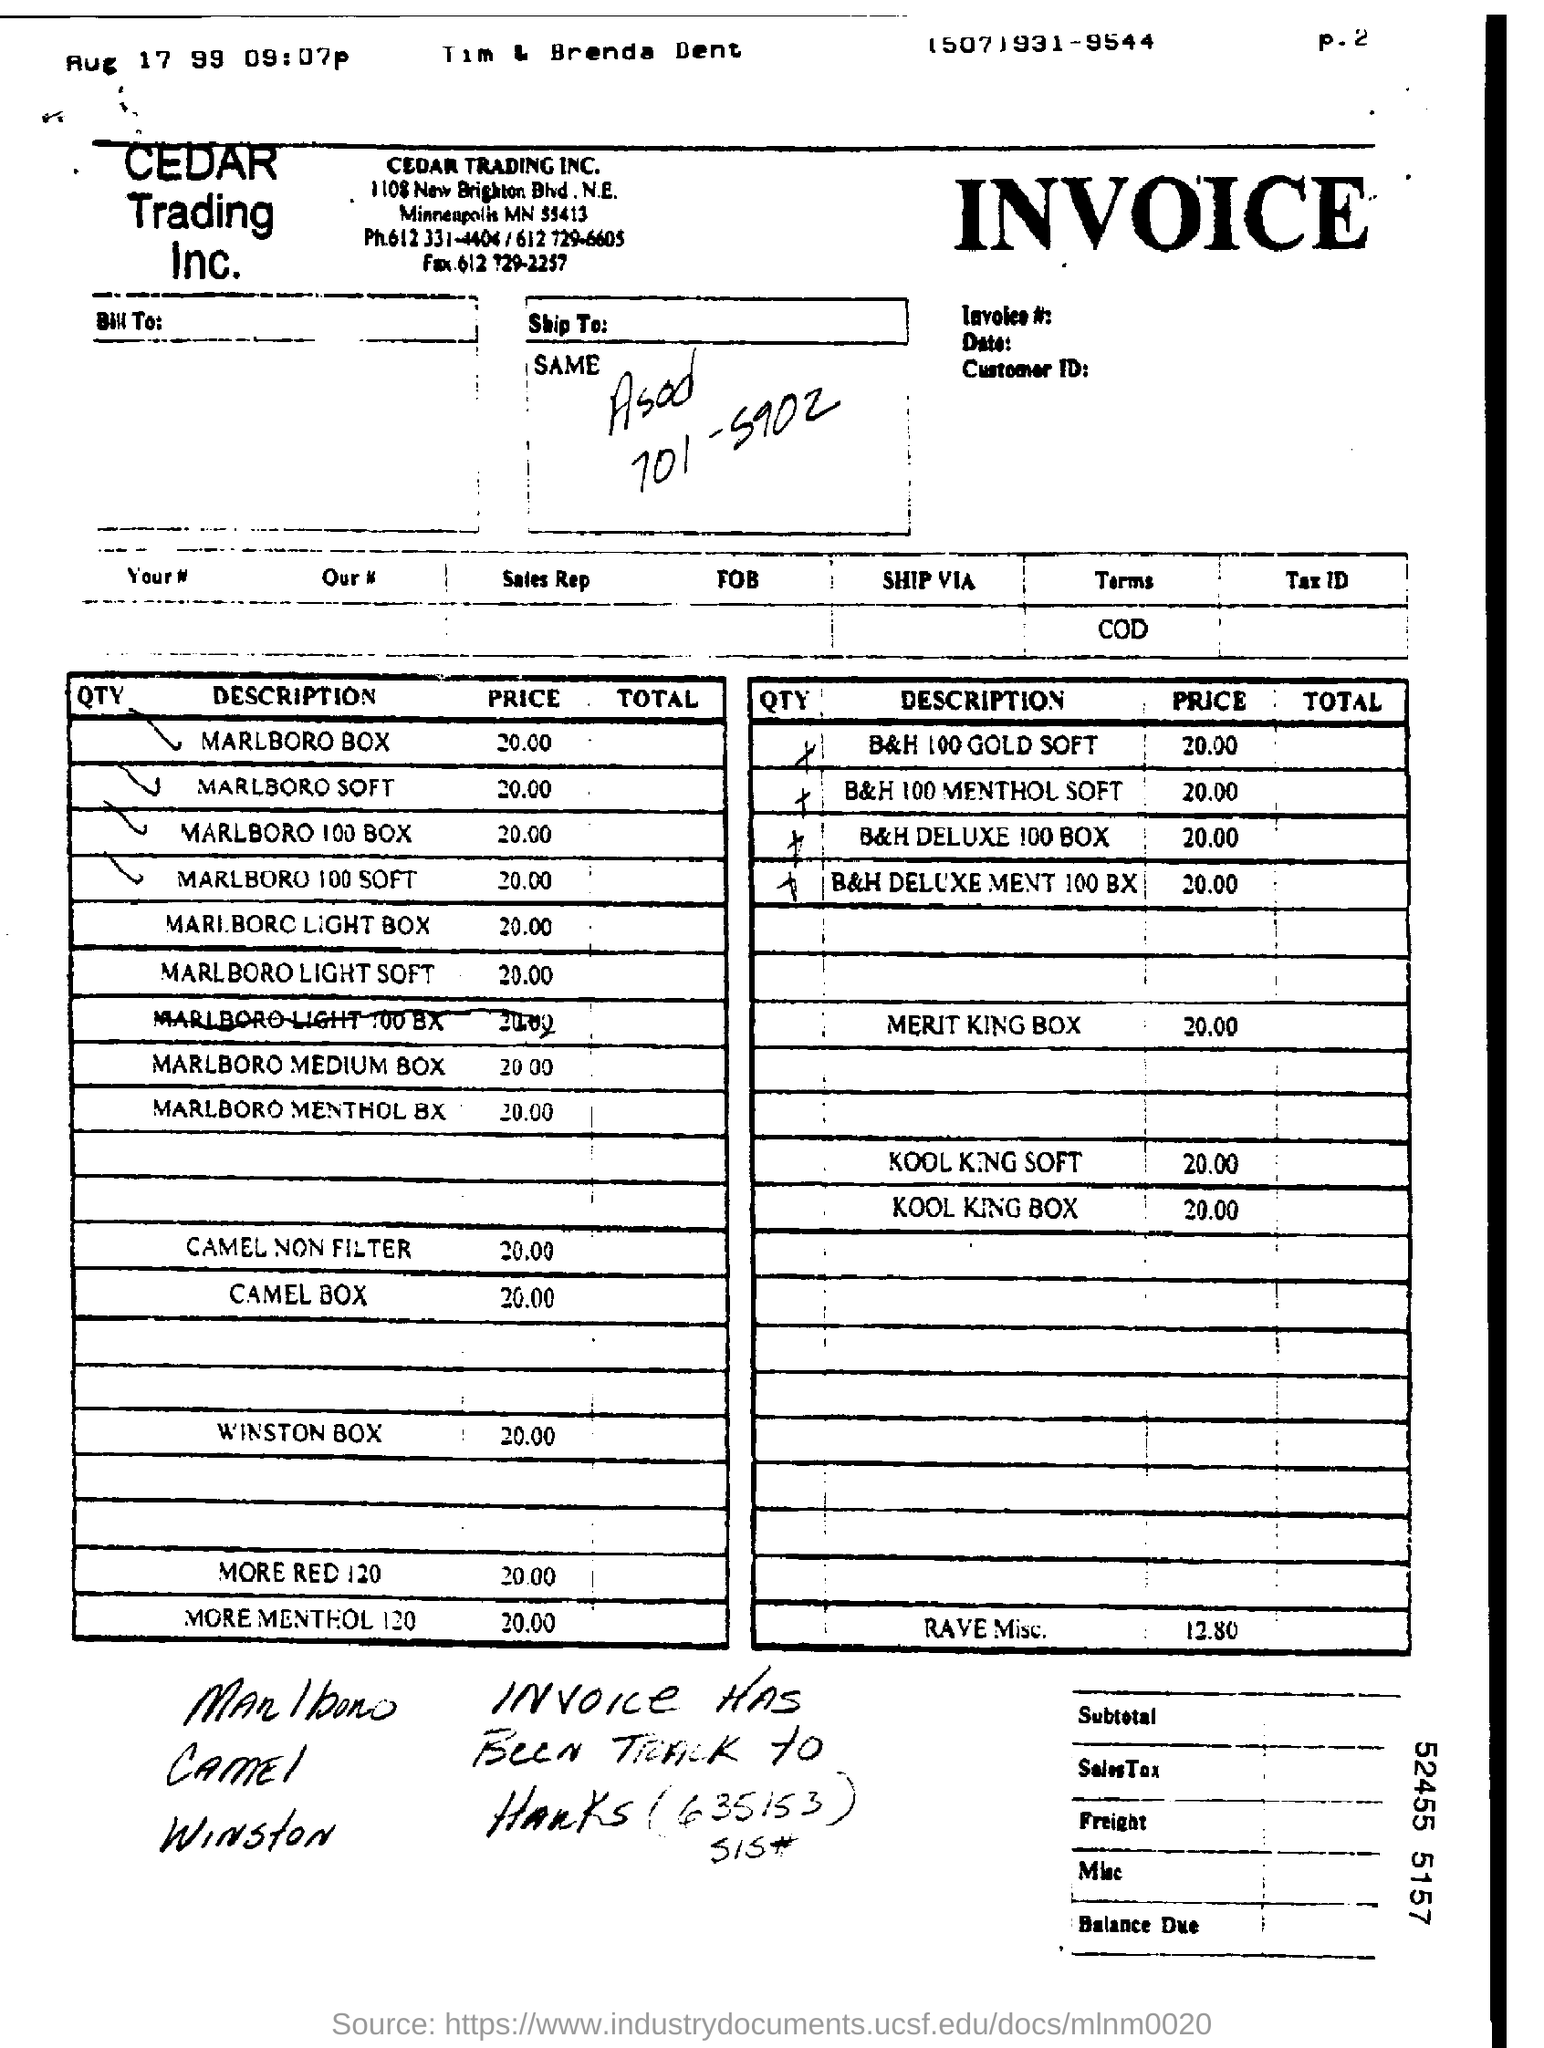Give some essential details in this illustration. The price for a Marlboro 100 box is 20.00. The price for a Marlboro box is 20.00. The price for a Marlboro Light box is $20.00. The price for a pack of Marlboro Soft cigarettes is $20.00. The price for a Marlboro medium box is 20.00. 